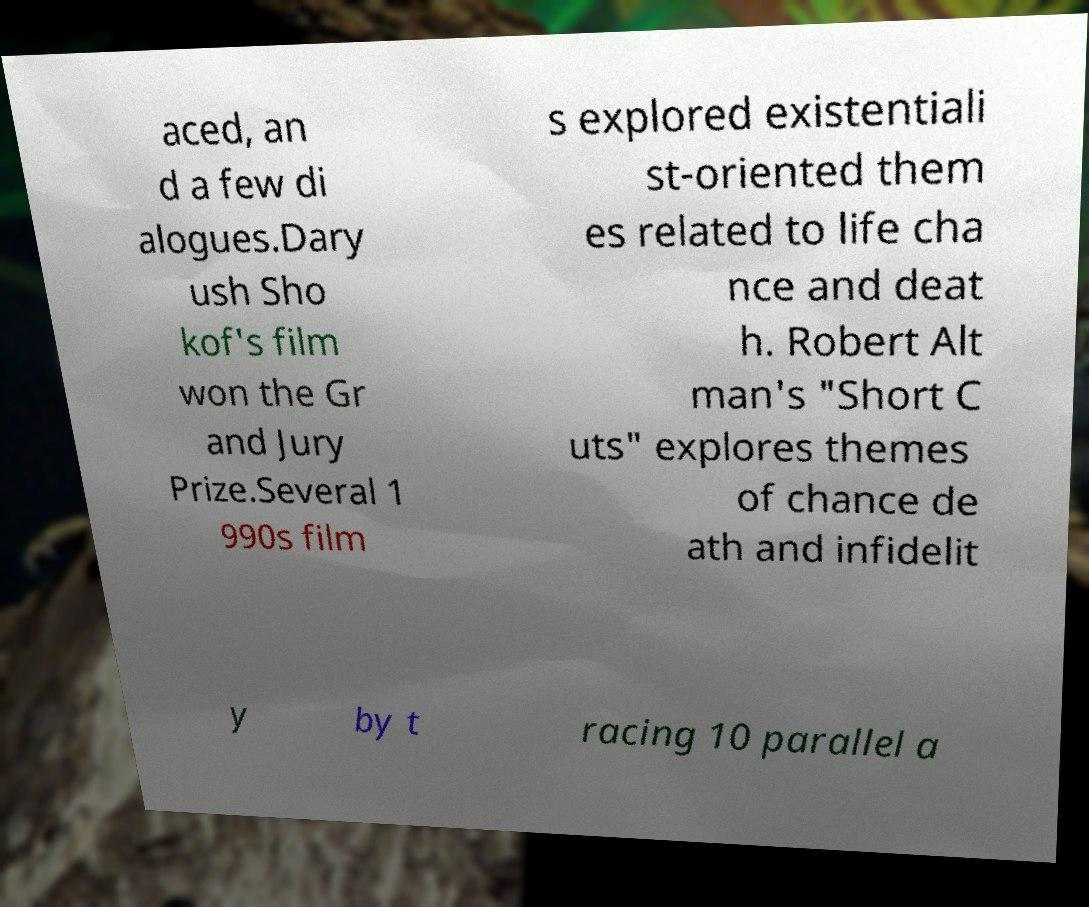Could you extract and type out the text from this image? aced, an d a few di alogues.Dary ush Sho kof's film won the Gr and Jury Prize.Several 1 990s film s explored existentiali st-oriented them es related to life cha nce and deat h. Robert Alt man's "Short C uts" explores themes of chance de ath and infidelit y by t racing 10 parallel a 